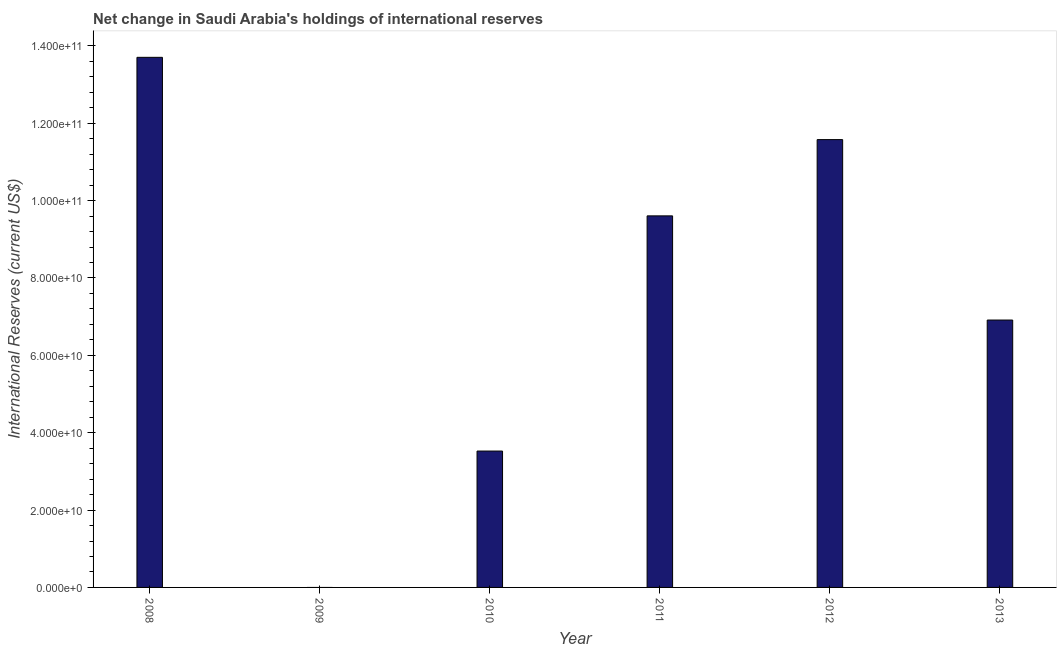What is the title of the graph?
Provide a short and direct response. Net change in Saudi Arabia's holdings of international reserves. What is the label or title of the Y-axis?
Give a very brief answer. International Reserves (current US$). What is the reserves and related items in 2008?
Keep it short and to the point. 1.37e+11. Across all years, what is the maximum reserves and related items?
Make the answer very short. 1.37e+11. What is the sum of the reserves and related items?
Your answer should be compact. 4.53e+11. What is the difference between the reserves and related items in 2008 and 2013?
Ensure brevity in your answer.  6.79e+1. What is the average reserves and related items per year?
Make the answer very short. 7.55e+1. What is the median reserves and related items?
Make the answer very short. 8.26e+1. In how many years, is the reserves and related items greater than 88000000000 US$?
Provide a short and direct response. 3. What is the ratio of the reserves and related items in 2010 to that in 2011?
Your answer should be very brief. 0.37. Is the reserves and related items in 2011 less than that in 2013?
Provide a short and direct response. No. Is the difference between the reserves and related items in 2010 and 2012 greater than the difference between any two years?
Provide a succinct answer. No. What is the difference between the highest and the second highest reserves and related items?
Offer a terse response. 2.13e+1. Is the sum of the reserves and related items in 2008 and 2011 greater than the maximum reserves and related items across all years?
Ensure brevity in your answer.  Yes. What is the difference between the highest and the lowest reserves and related items?
Your answer should be very brief. 1.37e+11. In how many years, is the reserves and related items greater than the average reserves and related items taken over all years?
Your answer should be very brief. 3. Are all the bars in the graph horizontal?
Your answer should be compact. No. What is the International Reserves (current US$) in 2008?
Make the answer very short. 1.37e+11. What is the International Reserves (current US$) in 2010?
Offer a terse response. 3.53e+1. What is the International Reserves (current US$) in 2011?
Offer a very short reply. 9.61e+1. What is the International Reserves (current US$) in 2012?
Your response must be concise. 1.16e+11. What is the International Reserves (current US$) of 2013?
Give a very brief answer. 6.91e+1. What is the difference between the International Reserves (current US$) in 2008 and 2010?
Your answer should be compact. 1.02e+11. What is the difference between the International Reserves (current US$) in 2008 and 2011?
Your response must be concise. 4.10e+1. What is the difference between the International Reserves (current US$) in 2008 and 2012?
Give a very brief answer. 2.13e+1. What is the difference between the International Reserves (current US$) in 2008 and 2013?
Your answer should be compact. 6.79e+1. What is the difference between the International Reserves (current US$) in 2010 and 2011?
Make the answer very short. -6.08e+1. What is the difference between the International Reserves (current US$) in 2010 and 2012?
Your answer should be very brief. -8.05e+1. What is the difference between the International Reserves (current US$) in 2010 and 2013?
Provide a succinct answer. -3.39e+1. What is the difference between the International Reserves (current US$) in 2011 and 2012?
Your answer should be compact. -1.97e+1. What is the difference between the International Reserves (current US$) in 2011 and 2013?
Your answer should be compact. 2.69e+1. What is the difference between the International Reserves (current US$) in 2012 and 2013?
Your response must be concise. 4.66e+1. What is the ratio of the International Reserves (current US$) in 2008 to that in 2010?
Keep it short and to the point. 3.89. What is the ratio of the International Reserves (current US$) in 2008 to that in 2011?
Your answer should be compact. 1.43. What is the ratio of the International Reserves (current US$) in 2008 to that in 2012?
Provide a short and direct response. 1.18. What is the ratio of the International Reserves (current US$) in 2008 to that in 2013?
Offer a very short reply. 1.98. What is the ratio of the International Reserves (current US$) in 2010 to that in 2011?
Your answer should be very brief. 0.37. What is the ratio of the International Reserves (current US$) in 2010 to that in 2012?
Give a very brief answer. 0.3. What is the ratio of the International Reserves (current US$) in 2010 to that in 2013?
Your response must be concise. 0.51. What is the ratio of the International Reserves (current US$) in 2011 to that in 2012?
Provide a short and direct response. 0.83. What is the ratio of the International Reserves (current US$) in 2011 to that in 2013?
Your answer should be compact. 1.39. What is the ratio of the International Reserves (current US$) in 2012 to that in 2013?
Your response must be concise. 1.68. 